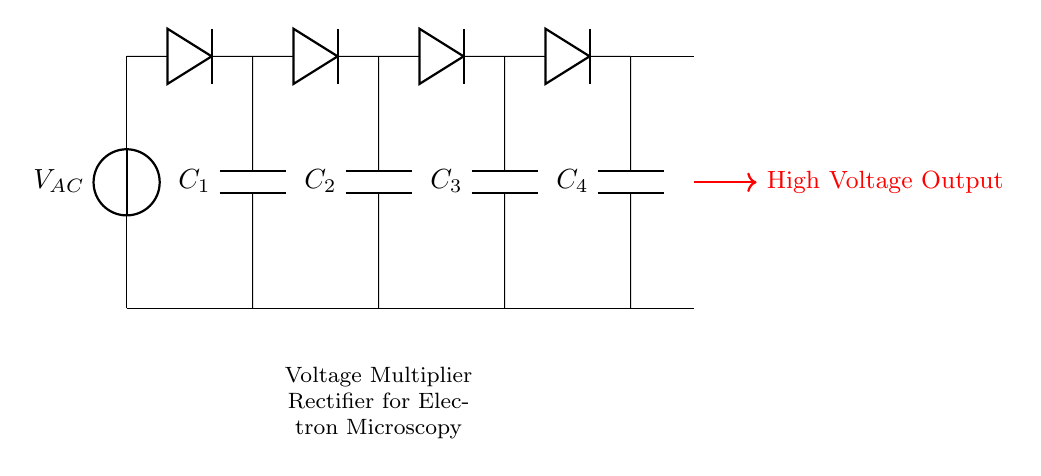What type of rectifier is represented in the circuit? The circuit primarily uses diodes for converting alternating current to direct current, which characterizes it as a rectifier.
Answer: Rectifier How many diodes are used in this circuit? The circuit features four diodes, as indicated by the symbols present in the diagram.
Answer: Four What components are used for voltage storage in this circuit? The circuit includes four capacitors, labeled as C1, C2, C3, and C4, which are used for storing voltage in the multiplier configuration.
Answer: Capacitors What is the orientation of the diodes in relation to the AC source? The orientation is such that they are connected to allow current to flow in one direction during their respective cycles of the AC voltage input.
Answer: Forward What is the expected output type of this circuit? Given the function of the circuit, the output is expected to be high-voltage direct current suitable for applications in electron microscopy.
Answer: High-voltage direct current How does the capacitor arrangement affect voltage generation? The capacitors are arranged to cumulatively charge and increase the overall voltage level through the multiplier effect, leading to a desired higher output voltage.
Answer: Increases output voltage What is the role of the voltage multiplier in this circuit? The voltage multiplier increases the voltage level output from the rectifier, enabling the generation of high voltages necessary for electron microscopy applications.
Answer: Generates high voltage 